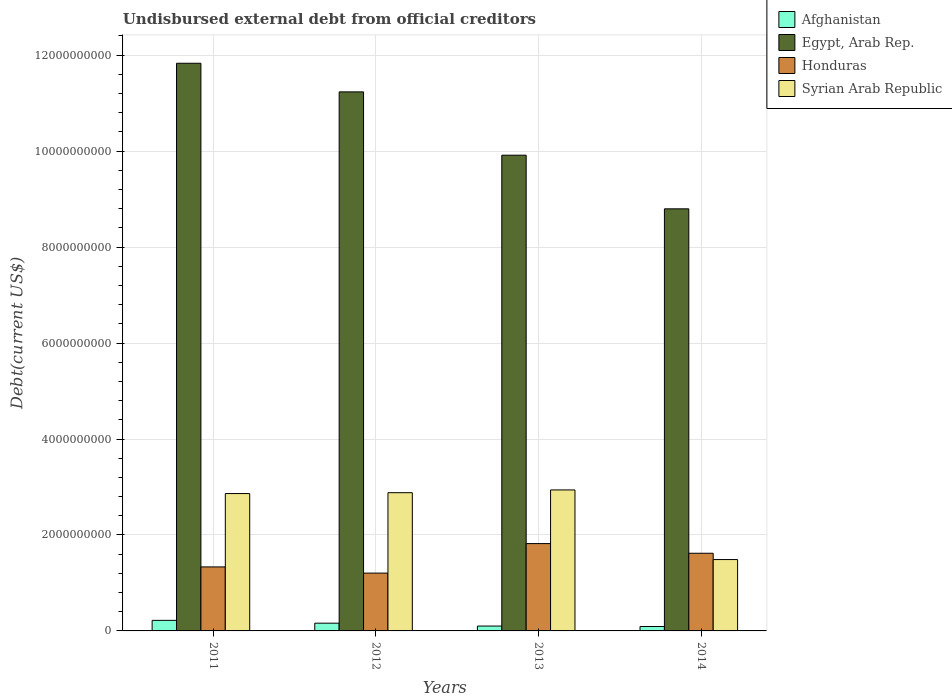How many different coloured bars are there?
Offer a very short reply. 4. Are the number of bars per tick equal to the number of legend labels?
Offer a terse response. Yes. What is the label of the 2nd group of bars from the left?
Keep it short and to the point. 2012. What is the total debt in Afghanistan in 2013?
Offer a terse response. 1.02e+08. Across all years, what is the maximum total debt in Syrian Arab Republic?
Your answer should be compact. 2.94e+09. Across all years, what is the minimum total debt in Syrian Arab Republic?
Offer a very short reply. 1.49e+09. What is the total total debt in Afghanistan in the graph?
Make the answer very short. 5.75e+08. What is the difference between the total debt in Syrian Arab Republic in 2011 and that in 2013?
Ensure brevity in your answer.  -7.55e+07. What is the difference between the total debt in Afghanistan in 2011 and the total debt in Honduras in 2014?
Keep it short and to the point. -1.40e+09. What is the average total debt in Syrian Arab Republic per year?
Your answer should be compact. 2.54e+09. In the year 2013, what is the difference between the total debt in Honduras and total debt in Afghanistan?
Provide a short and direct response. 1.72e+09. In how many years, is the total debt in Egypt, Arab Rep. greater than 1200000000 US$?
Make the answer very short. 4. What is the ratio of the total debt in Honduras in 2012 to that in 2014?
Make the answer very short. 0.74. Is the total debt in Afghanistan in 2011 less than that in 2012?
Make the answer very short. No. Is the difference between the total debt in Honduras in 2011 and 2012 greater than the difference between the total debt in Afghanistan in 2011 and 2012?
Provide a succinct answer. Yes. What is the difference between the highest and the second highest total debt in Honduras?
Give a very brief answer. 2.02e+08. What is the difference between the highest and the lowest total debt in Egypt, Arab Rep.?
Provide a short and direct response. 3.03e+09. In how many years, is the total debt in Honduras greater than the average total debt in Honduras taken over all years?
Offer a very short reply. 2. Is the sum of the total debt in Afghanistan in 2013 and 2014 greater than the maximum total debt in Egypt, Arab Rep. across all years?
Your response must be concise. No. Is it the case that in every year, the sum of the total debt in Honduras and total debt in Syrian Arab Republic is greater than the sum of total debt in Egypt, Arab Rep. and total debt in Afghanistan?
Keep it short and to the point. Yes. What does the 4th bar from the left in 2014 represents?
Provide a succinct answer. Syrian Arab Republic. What does the 3rd bar from the right in 2011 represents?
Your answer should be very brief. Egypt, Arab Rep. Is it the case that in every year, the sum of the total debt in Honduras and total debt in Syrian Arab Republic is greater than the total debt in Afghanistan?
Your answer should be compact. Yes. How many bars are there?
Offer a very short reply. 16. Are all the bars in the graph horizontal?
Your answer should be very brief. No. How many years are there in the graph?
Ensure brevity in your answer.  4. Does the graph contain any zero values?
Your response must be concise. No. Does the graph contain grids?
Your answer should be compact. Yes. Where does the legend appear in the graph?
Keep it short and to the point. Top right. What is the title of the graph?
Provide a succinct answer. Undisbursed external debt from official creditors. What is the label or title of the Y-axis?
Provide a short and direct response. Debt(current US$). What is the Debt(current US$) of Afghanistan in 2011?
Ensure brevity in your answer.  2.20e+08. What is the Debt(current US$) of Egypt, Arab Rep. in 2011?
Keep it short and to the point. 1.18e+1. What is the Debt(current US$) in Honduras in 2011?
Make the answer very short. 1.33e+09. What is the Debt(current US$) of Syrian Arab Republic in 2011?
Offer a terse response. 2.86e+09. What is the Debt(current US$) in Afghanistan in 2012?
Offer a terse response. 1.61e+08. What is the Debt(current US$) of Egypt, Arab Rep. in 2012?
Provide a succinct answer. 1.12e+1. What is the Debt(current US$) of Honduras in 2012?
Give a very brief answer. 1.20e+09. What is the Debt(current US$) in Syrian Arab Republic in 2012?
Ensure brevity in your answer.  2.88e+09. What is the Debt(current US$) of Afghanistan in 2013?
Keep it short and to the point. 1.02e+08. What is the Debt(current US$) in Egypt, Arab Rep. in 2013?
Give a very brief answer. 9.92e+09. What is the Debt(current US$) in Honduras in 2013?
Offer a very short reply. 1.82e+09. What is the Debt(current US$) in Syrian Arab Republic in 2013?
Offer a terse response. 2.94e+09. What is the Debt(current US$) in Afghanistan in 2014?
Ensure brevity in your answer.  9.24e+07. What is the Debt(current US$) of Egypt, Arab Rep. in 2014?
Your response must be concise. 8.80e+09. What is the Debt(current US$) of Honduras in 2014?
Make the answer very short. 1.62e+09. What is the Debt(current US$) of Syrian Arab Republic in 2014?
Your answer should be very brief. 1.49e+09. Across all years, what is the maximum Debt(current US$) of Afghanistan?
Keep it short and to the point. 2.20e+08. Across all years, what is the maximum Debt(current US$) of Egypt, Arab Rep.?
Give a very brief answer. 1.18e+1. Across all years, what is the maximum Debt(current US$) of Honduras?
Offer a terse response. 1.82e+09. Across all years, what is the maximum Debt(current US$) of Syrian Arab Republic?
Offer a terse response. 2.94e+09. Across all years, what is the minimum Debt(current US$) in Afghanistan?
Your response must be concise. 9.24e+07. Across all years, what is the minimum Debt(current US$) in Egypt, Arab Rep.?
Your answer should be very brief. 8.80e+09. Across all years, what is the minimum Debt(current US$) in Honduras?
Your response must be concise. 1.20e+09. Across all years, what is the minimum Debt(current US$) in Syrian Arab Republic?
Your answer should be compact. 1.49e+09. What is the total Debt(current US$) in Afghanistan in the graph?
Ensure brevity in your answer.  5.75e+08. What is the total Debt(current US$) in Egypt, Arab Rep. in the graph?
Ensure brevity in your answer.  4.18e+1. What is the total Debt(current US$) of Honduras in the graph?
Provide a succinct answer. 5.98e+09. What is the total Debt(current US$) in Syrian Arab Republic in the graph?
Offer a terse response. 1.02e+1. What is the difference between the Debt(current US$) of Afghanistan in 2011 and that in 2012?
Ensure brevity in your answer.  5.87e+07. What is the difference between the Debt(current US$) in Egypt, Arab Rep. in 2011 and that in 2012?
Offer a terse response. 5.96e+08. What is the difference between the Debt(current US$) in Honduras in 2011 and that in 2012?
Provide a short and direct response. 1.29e+08. What is the difference between the Debt(current US$) of Syrian Arab Republic in 2011 and that in 2012?
Provide a succinct answer. -1.79e+07. What is the difference between the Debt(current US$) of Afghanistan in 2011 and that in 2013?
Ensure brevity in your answer.  1.18e+08. What is the difference between the Debt(current US$) of Egypt, Arab Rep. in 2011 and that in 2013?
Make the answer very short. 1.92e+09. What is the difference between the Debt(current US$) in Honduras in 2011 and that in 2013?
Make the answer very short. -4.86e+08. What is the difference between the Debt(current US$) in Syrian Arab Republic in 2011 and that in 2013?
Offer a terse response. -7.55e+07. What is the difference between the Debt(current US$) of Afghanistan in 2011 and that in 2014?
Your response must be concise. 1.28e+08. What is the difference between the Debt(current US$) of Egypt, Arab Rep. in 2011 and that in 2014?
Offer a terse response. 3.03e+09. What is the difference between the Debt(current US$) of Honduras in 2011 and that in 2014?
Your response must be concise. -2.85e+08. What is the difference between the Debt(current US$) of Syrian Arab Republic in 2011 and that in 2014?
Your response must be concise. 1.38e+09. What is the difference between the Debt(current US$) of Afghanistan in 2012 and that in 2013?
Ensure brevity in your answer.  5.97e+07. What is the difference between the Debt(current US$) in Egypt, Arab Rep. in 2012 and that in 2013?
Make the answer very short. 1.32e+09. What is the difference between the Debt(current US$) in Honduras in 2012 and that in 2013?
Offer a terse response. -6.15e+08. What is the difference between the Debt(current US$) of Syrian Arab Republic in 2012 and that in 2013?
Ensure brevity in your answer.  -5.76e+07. What is the difference between the Debt(current US$) of Afghanistan in 2012 and that in 2014?
Make the answer very short. 6.89e+07. What is the difference between the Debt(current US$) in Egypt, Arab Rep. in 2012 and that in 2014?
Offer a very short reply. 2.44e+09. What is the difference between the Debt(current US$) of Honduras in 2012 and that in 2014?
Offer a terse response. -4.14e+08. What is the difference between the Debt(current US$) of Syrian Arab Republic in 2012 and that in 2014?
Provide a short and direct response. 1.39e+09. What is the difference between the Debt(current US$) in Afghanistan in 2013 and that in 2014?
Your answer should be compact. 9.12e+06. What is the difference between the Debt(current US$) in Egypt, Arab Rep. in 2013 and that in 2014?
Your response must be concise. 1.12e+09. What is the difference between the Debt(current US$) of Honduras in 2013 and that in 2014?
Your answer should be compact. 2.02e+08. What is the difference between the Debt(current US$) of Syrian Arab Republic in 2013 and that in 2014?
Make the answer very short. 1.45e+09. What is the difference between the Debt(current US$) in Afghanistan in 2011 and the Debt(current US$) in Egypt, Arab Rep. in 2012?
Your response must be concise. -1.10e+1. What is the difference between the Debt(current US$) of Afghanistan in 2011 and the Debt(current US$) of Honduras in 2012?
Provide a succinct answer. -9.85e+08. What is the difference between the Debt(current US$) of Afghanistan in 2011 and the Debt(current US$) of Syrian Arab Republic in 2012?
Keep it short and to the point. -2.66e+09. What is the difference between the Debt(current US$) in Egypt, Arab Rep. in 2011 and the Debt(current US$) in Honduras in 2012?
Offer a terse response. 1.06e+1. What is the difference between the Debt(current US$) in Egypt, Arab Rep. in 2011 and the Debt(current US$) in Syrian Arab Republic in 2012?
Provide a succinct answer. 8.95e+09. What is the difference between the Debt(current US$) in Honduras in 2011 and the Debt(current US$) in Syrian Arab Republic in 2012?
Give a very brief answer. -1.55e+09. What is the difference between the Debt(current US$) in Afghanistan in 2011 and the Debt(current US$) in Egypt, Arab Rep. in 2013?
Your response must be concise. -9.70e+09. What is the difference between the Debt(current US$) of Afghanistan in 2011 and the Debt(current US$) of Honduras in 2013?
Offer a very short reply. -1.60e+09. What is the difference between the Debt(current US$) in Afghanistan in 2011 and the Debt(current US$) in Syrian Arab Republic in 2013?
Your answer should be compact. -2.72e+09. What is the difference between the Debt(current US$) of Egypt, Arab Rep. in 2011 and the Debt(current US$) of Honduras in 2013?
Offer a very short reply. 1.00e+1. What is the difference between the Debt(current US$) in Egypt, Arab Rep. in 2011 and the Debt(current US$) in Syrian Arab Republic in 2013?
Offer a terse response. 8.89e+09. What is the difference between the Debt(current US$) in Honduras in 2011 and the Debt(current US$) in Syrian Arab Republic in 2013?
Provide a succinct answer. -1.60e+09. What is the difference between the Debt(current US$) of Afghanistan in 2011 and the Debt(current US$) of Egypt, Arab Rep. in 2014?
Your response must be concise. -8.58e+09. What is the difference between the Debt(current US$) of Afghanistan in 2011 and the Debt(current US$) of Honduras in 2014?
Offer a very short reply. -1.40e+09. What is the difference between the Debt(current US$) in Afghanistan in 2011 and the Debt(current US$) in Syrian Arab Republic in 2014?
Offer a terse response. -1.27e+09. What is the difference between the Debt(current US$) in Egypt, Arab Rep. in 2011 and the Debt(current US$) in Honduras in 2014?
Provide a short and direct response. 1.02e+1. What is the difference between the Debt(current US$) of Egypt, Arab Rep. in 2011 and the Debt(current US$) of Syrian Arab Republic in 2014?
Give a very brief answer. 1.03e+1. What is the difference between the Debt(current US$) of Honduras in 2011 and the Debt(current US$) of Syrian Arab Republic in 2014?
Ensure brevity in your answer.  -1.53e+08. What is the difference between the Debt(current US$) in Afghanistan in 2012 and the Debt(current US$) in Egypt, Arab Rep. in 2013?
Provide a short and direct response. -9.75e+09. What is the difference between the Debt(current US$) of Afghanistan in 2012 and the Debt(current US$) of Honduras in 2013?
Provide a short and direct response. -1.66e+09. What is the difference between the Debt(current US$) in Afghanistan in 2012 and the Debt(current US$) in Syrian Arab Republic in 2013?
Provide a succinct answer. -2.78e+09. What is the difference between the Debt(current US$) in Egypt, Arab Rep. in 2012 and the Debt(current US$) in Honduras in 2013?
Keep it short and to the point. 9.41e+09. What is the difference between the Debt(current US$) of Egypt, Arab Rep. in 2012 and the Debt(current US$) of Syrian Arab Republic in 2013?
Provide a succinct answer. 8.30e+09. What is the difference between the Debt(current US$) in Honduras in 2012 and the Debt(current US$) in Syrian Arab Republic in 2013?
Ensure brevity in your answer.  -1.73e+09. What is the difference between the Debt(current US$) in Afghanistan in 2012 and the Debt(current US$) in Egypt, Arab Rep. in 2014?
Provide a short and direct response. -8.64e+09. What is the difference between the Debt(current US$) in Afghanistan in 2012 and the Debt(current US$) in Honduras in 2014?
Your response must be concise. -1.46e+09. What is the difference between the Debt(current US$) in Afghanistan in 2012 and the Debt(current US$) in Syrian Arab Republic in 2014?
Ensure brevity in your answer.  -1.33e+09. What is the difference between the Debt(current US$) in Egypt, Arab Rep. in 2012 and the Debt(current US$) in Honduras in 2014?
Your answer should be very brief. 9.62e+09. What is the difference between the Debt(current US$) in Egypt, Arab Rep. in 2012 and the Debt(current US$) in Syrian Arab Republic in 2014?
Your response must be concise. 9.75e+09. What is the difference between the Debt(current US$) in Honduras in 2012 and the Debt(current US$) in Syrian Arab Republic in 2014?
Your response must be concise. -2.82e+08. What is the difference between the Debt(current US$) of Afghanistan in 2013 and the Debt(current US$) of Egypt, Arab Rep. in 2014?
Make the answer very short. -8.70e+09. What is the difference between the Debt(current US$) in Afghanistan in 2013 and the Debt(current US$) in Honduras in 2014?
Your response must be concise. -1.52e+09. What is the difference between the Debt(current US$) of Afghanistan in 2013 and the Debt(current US$) of Syrian Arab Republic in 2014?
Offer a very short reply. -1.39e+09. What is the difference between the Debt(current US$) in Egypt, Arab Rep. in 2013 and the Debt(current US$) in Honduras in 2014?
Ensure brevity in your answer.  8.30e+09. What is the difference between the Debt(current US$) of Egypt, Arab Rep. in 2013 and the Debt(current US$) of Syrian Arab Republic in 2014?
Offer a very short reply. 8.43e+09. What is the difference between the Debt(current US$) in Honduras in 2013 and the Debt(current US$) in Syrian Arab Republic in 2014?
Keep it short and to the point. 3.33e+08. What is the average Debt(current US$) in Afghanistan per year?
Your answer should be very brief. 1.44e+08. What is the average Debt(current US$) of Egypt, Arab Rep. per year?
Make the answer very short. 1.04e+1. What is the average Debt(current US$) in Honduras per year?
Provide a succinct answer. 1.49e+09. What is the average Debt(current US$) of Syrian Arab Republic per year?
Your answer should be compact. 2.54e+09. In the year 2011, what is the difference between the Debt(current US$) in Afghanistan and Debt(current US$) in Egypt, Arab Rep.?
Provide a succinct answer. -1.16e+1. In the year 2011, what is the difference between the Debt(current US$) of Afghanistan and Debt(current US$) of Honduras?
Give a very brief answer. -1.11e+09. In the year 2011, what is the difference between the Debt(current US$) in Afghanistan and Debt(current US$) in Syrian Arab Republic?
Your answer should be very brief. -2.64e+09. In the year 2011, what is the difference between the Debt(current US$) in Egypt, Arab Rep. and Debt(current US$) in Honduras?
Provide a succinct answer. 1.05e+1. In the year 2011, what is the difference between the Debt(current US$) in Egypt, Arab Rep. and Debt(current US$) in Syrian Arab Republic?
Make the answer very short. 8.97e+09. In the year 2011, what is the difference between the Debt(current US$) in Honduras and Debt(current US$) in Syrian Arab Republic?
Keep it short and to the point. -1.53e+09. In the year 2012, what is the difference between the Debt(current US$) of Afghanistan and Debt(current US$) of Egypt, Arab Rep.?
Ensure brevity in your answer.  -1.11e+1. In the year 2012, what is the difference between the Debt(current US$) in Afghanistan and Debt(current US$) in Honduras?
Make the answer very short. -1.04e+09. In the year 2012, what is the difference between the Debt(current US$) of Afghanistan and Debt(current US$) of Syrian Arab Republic?
Offer a very short reply. -2.72e+09. In the year 2012, what is the difference between the Debt(current US$) in Egypt, Arab Rep. and Debt(current US$) in Honduras?
Provide a succinct answer. 1.00e+1. In the year 2012, what is the difference between the Debt(current US$) in Egypt, Arab Rep. and Debt(current US$) in Syrian Arab Republic?
Give a very brief answer. 8.35e+09. In the year 2012, what is the difference between the Debt(current US$) of Honduras and Debt(current US$) of Syrian Arab Republic?
Provide a succinct answer. -1.68e+09. In the year 2013, what is the difference between the Debt(current US$) of Afghanistan and Debt(current US$) of Egypt, Arab Rep.?
Ensure brevity in your answer.  -9.81e+09. In the year 2013, what is the difference between the Debt(current US$) in Afghanistan and Debt(current US$) in Honduras?
Offer a terse response. -1.72e+09. In the year 2013, what is the difference between the Debt(current US$) of Afghanistan and Debt(current US$) of Syrian Arab Republic?
Keep it short and to the point. -2.84e+09. In the year 2013, what is the difference between the Debt(current US$) in Egypt, Arab Rep. and Debt(current US$) in Honduras?
Keep it short and to the point. 8.09e+09. In the year 2013, what is the difference between the Debt(current US$) in Egypt, Arab Rep. and Debt(current US$) in Syrian Arab Republic?
Provide a short and direct response. 6.98e+09. In the year 2013, what is the difference between the Debt(current US$) of Honduras and Debt(current US$) of Syrian Arab Republic?
Offer a very short reply. -1.12e+09. In the year 2014, what is the difference between the Debt(current US$) of Afghanistan and Debt(current US$) of Egypt, Arab Rep.?
Provide a short and direct response. -8.70e+09. In the year 2014, what is the difference between the Debt(current US$) of Afghanistan and Debt(current US$) of Honduras?
Your response must be concise. -1.53e+09. In the year 2014, what is the difference between the Debt(current US$) in Afghanistan and Debt(current US$) in Syrian Arab Republic?
Your answer should be very brief. -1.40e+09. In the year 2014, what is the difference between the Debt(current US$) in Egypt, Arab Rep. and Debt(current US$) in Honduras?
Offer a terse response. 7.18e+09. In the year 2014, what is the difference between the Debt(current US$) in Egypt, Arab Rep. and Debt(current US$) in Syrian Arab Republic?
Make the answer very short. 7.31e+09. In the year 2014, what is the difference between the Debt(current US$) in Honduras and Debt(current US$) in Syrian Arab Republic?
Offer a terse response. 1.31e+08. What is the ratio of the Debt(current US$) of Afghanistan in 2011 to that in 2012?
Your answer should be very brief. 1.36. What is the ratio of the Debt(current US$) of Egypt, Arab Rep. in 2011 to that in 2012?
Your answer should be compact. 1.05. What is the ratio of the Debt(current US$) of Honduras in 2011 to that in 2012?
Offer a terse response. 1.11. What is the ratio of the Debt(current US$) of Afghanistan in 2011 to that in 2013?
Provide a succinct answer. 2.17. What is the ratio of the Debt(current US$) in Egypt, Arab Rep. in 2011 to that in 2013?
Offer a terse response. 1.19. What is the ratio of the Debt(current US$) in Honduras in 2011 to that in 2013?
Give a very brief answer. 0.73. What is the ratio of the Debt(current US$) in Syrian Arab Republic in 2011 to that in 2013?
Your answer should be compact. 0.97. What is the ratio of the Debt(current US$) of Afghanistan in 2011 to that in 2014?
Ensure brevity in your answer.  2.38. What is the ratio of the Debt(current US$) of Egypt, Arab Rep. in 2011 to that in 2014?
Offer a very short reply. 1.34. What is the ratio of the Debt(current US$) in Honduras in 2011 to that in 2014?
Offer a very short reply. 0.82. What is the ratio of the Debt(current US$) of Syrian Arab Republic in 2011 to that in 2014?
Your answer should be very brief. 1.92. What is the ratio of the Debt(current US$) in Afghanistan in 2012 to that in 2013?
Provide a short and direct response. 1.59. What is the ratio of the Debt(current US$) of Egypt, Arab Rep. in 2012 to that in 2013?
Offer a very short reply. 1.13. What is the ratio of the Debt(current US$) in Honduras in 2012 to that in 2013?
Offer a terse response. 0.66. What is the ratio of the Debt(current US$) in Syrian Arab Republic in 2012 to that in 2013?
Provide a succinct answer. 0.98. What is the ratio of the Debt(current US$) in Afghanistan in 2012 to that in 2014?
Keep it short and to the point. 1.75. What is the ratio of the Debt(current US$) of Egypt, Arab Rep. in 2012 to that in 2014?
Your answer should be very brief. 1.28. What is the ratio of the Debt(current US$) in Honduras in 2012 to that in 2014?
Offer a very short reply. 0.74. What is the ratio of the Debt(current US$) of Syrian Arab Republic in 2012 to that in 2014?
Offer a terse response. 1.94. What is the ratio of the Debt(current US$) in Afghanistan in 2013 to that in 2014?
Offer a terse response. 1.1. What is the ratio of the Debt(current US$) in Egypt, Arab Rep. in 2013 to that in 2014?
Your answer should be very brief. 1.13. What is the ratio of the Debt(current US$) of Honduras in 2013 to that in 2014?
Keep it short and to the point. 1.12. What is the ratio of the Debt(current US$) in Syrian Arab Republic in 2013 to that in 2014?
Your answer should be very brief. 1.98. What is the difference between the highest and the second highest Debt(current US$) of Afghanistan?
Provide a short and direct response. 5.87e+07. What is the difference between the highest and the second highest Debt(current US$) of Egypt, Arab Rep.?
Make the answer very short. 5.96e+08. What is the difference between the highest and the second highest Debt(current US$) in Honduras?
Your response must be concise. 2.02e+08. What is the difference between the highest and the second highest Debt(current US$) in Syrian Arab Republic?
Provide a succinct answer. 5.76e+07. What is the difference between the highest and the lowest Debt(current US$) in Afghanistan?
Offer a terse response. 1.28e+08. What is the difference between the highest and the lowest Debt(current US$) of Egypt, Arab Rep.?
Keep it short and to the point. 3.03e+09. What is the difference between the highest and the lowest Debt(current US$) in Honduras?
Give a very brief answer. 6.15e+08. What is the difference between the highest and the lowest Debt(current US$) of Syrian Arab Republic?
Your response must be concise. 1.45e+09. 